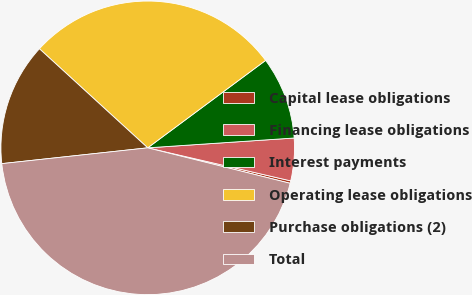<chart> <loc_0><loc_0><loc_500><loc_500><pie_chart><fcel>Capital lease obligations<fcel>Financing lease obligations<fcel>Interest payments<fcel>Operating lease obligations<fcel>Purchase obligations (2)<fcel>Total<nl><fcel>0.27%<fcel>4.68%<fcel>9.09%<fcel>28.05%<fcel>13.51%<fcel>44.4%<nl></chart> 